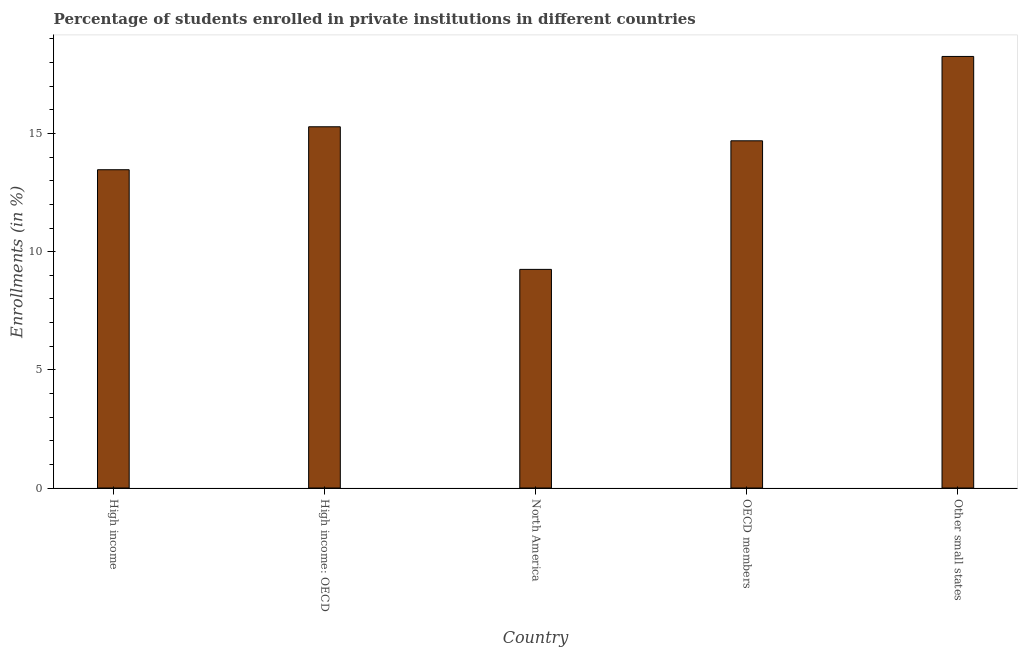Does the graph contain grids?
Your answer should be very brief. No. What is the title of the graph?
Keep it short and to the point. Percentage of students enrolled in private institutions in different countries. What is the label or title of the X-axis?
Keep it short and to the point. Country. What is the label or title of the Y-axis?
Keep it short and to the point. Enrollments (in %). What is the enrollments in private institutions in High income?
Give a very brief answer. 13.47. Across all countries, what is the maximum enrollments in private institutions?
Offer a very short reply. 18.26. Across all countries, what is the minimum enrollments in private institutions?
Offer a very short reply. 9.25. In which country was the enrollments in private institutions maximum?
Your response must be concise. Other small states. In which country was the enrollments in private institutions minimum?
Make the answer very short. North America. What is the sum of the enrollments in private institutions?
Ensure brevity in your answer.  70.95. What is the difference between the enrollments in private institutions in High income: OECD and OECD members?
Give a very brief answer. 0.59. What is the average enrollments in private institutions per country?
Keep it short and to the point. 14.19. What is the median enrollments in private institutions?
Ensure brevity in your answer.  14.69. What is the ratio of the enrollments in private institutions in High income to that in High income: OECD?
Provide a short and direct response. 0.88. Is the enrollments in private institutions in High income: OECD less than that in Other small states?
Give a very brief answer. Yes. Is the difference between the enrollments in private institutions in High income and High income: OECD greater than the difference between any two countries?
Your answer should be very brief. No. What is the difference between the highest and the second highest enrollments in private institutions?
Offer a very short reply. 2.98. What is the difference between the highest and the lowest enrollments in private institutions?
Ensure brevity in your answer.  9.01. In how many countries, is the enrollments in private institutions greater than the average enrollments in private institutions taken over all countries?
Offer a terse response. 3. How many bars are there?
Make the answer very short. 5. Are all the bars in the graph horizontal?
Provide a short and direct response. No. What is the difference between two consecutive major ticks on the Y-axis?
Give a very brief answer. 5. What is the Enrollments (in %) of High income?
Offer a terse response. 13.47. What is the Enrollments (in %) of High income: OECD?
Provide a succinct answer. 15.28. What is the Enrollments (in %) in North America?
Provide a succinct answer. 9.25. What is the Enrollments (in %) in OECD members?
Provide a succinct answer. 14.69. What is the Enrollments (in %) of Other small states?
Your response must be concise. 18.26. What is the difference between the Enrollments (in %) in High income and High income: OECD?
Give a very brief answer. -1.82. What is the difference between the Enrollments (in %) in High income and North America?
Keep it short and to the point. 4.22. What is the difference between the Enrollments (in %) in High income and OECD members?
Make the answer very short. -1.22. What is the difference between the Enrollments (in %) in High income and Other small states?
Offer a very short reply. -4.79. What is the difference between the Enrollments (in %) in High income: OECD and North America?
Your response must be concise. 6.03. What is the difference between the Enrollments (in %) in High income: OECD and OECD members?
Keep it short and to the point. 0.59. What is the difference between the Enrollments (in %) in High income: OECD and Other small states?
Provide a succinct answer. -2.97. What is the difference between the Enrollments (in %) in North America and OECD members?
Provide a succinct answer. -5.44. What is the difference between the Enrollments (in %) in North America and Other small states?
Provide a succinct answer. -9.01. What is the difference between the Enrollments (in %) in OECD members and Other small states?
Provide a succinct answer. -3.57. What is the ratio of the Enrollments (in %) in High income to that in High income: OECD?
Give a very brief answer. 0.88. What is the ratio of the Enrollments (in %) in High income to that in North America?
Provide a succinct answer. 1.46. What is the ratio of the Enrollments (in %) in High income to that in OECD members?
Your answer should be compact. 0.92. What is the ratio of the Enrollments (in %) in High income to that in Other small states?
Offer a very short reply. 0.74. What is the ratio of the Enrollments (in %) in High income: OECD to that in North America?
Your answer should be very brief. 1.65. What is the ratio of the Enrollments (in %) in High income: OECD to that in Other small states?
Provide a succinct answer. 0.84. What is the ratio of the Enrollments (in %) in North America to that in OECD members?
Your answer should be compact. 0.63. What is the ratio of the Enrollments (in %) in North America to that in Other small states?
Offer a terse response. 0.51. What is the ratio of the Enrollments (in %) in OECD members to that in Other small states?
Keep it short and to the point. 0.81. 